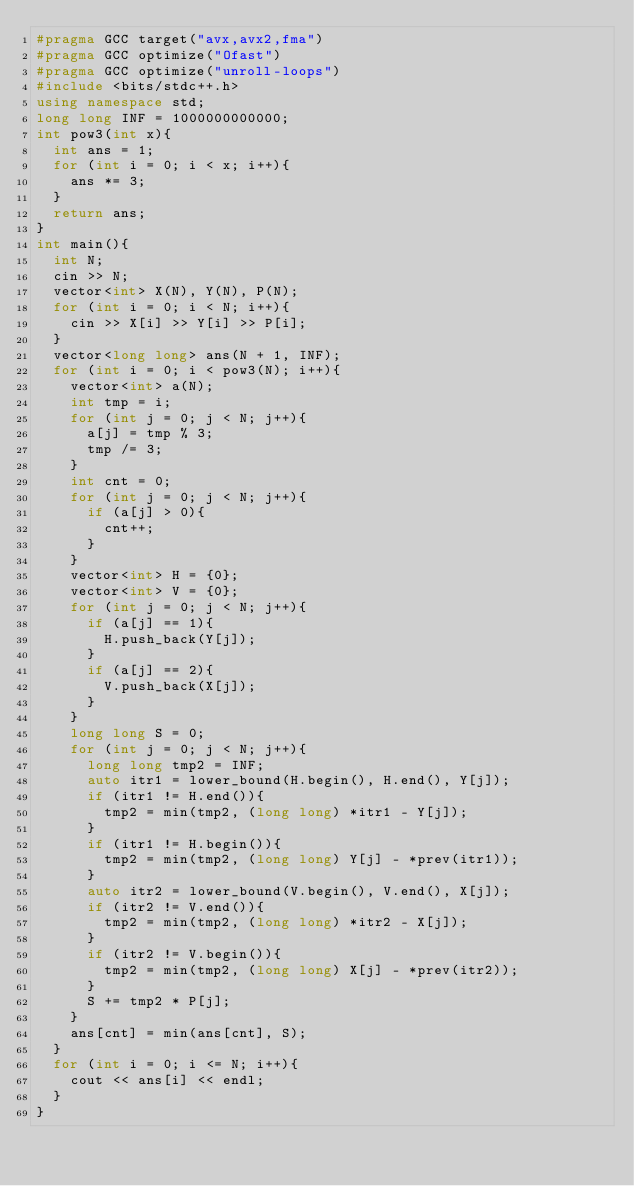<code> <loc_0><loc_0><loc_500><loc_500><_C++_>#pragma GCC target("avx,avx2,fma")
#pragma GCC optimize("Ofast")
#pragma GCC optimize("unroll-loops")
#include <bits/stdc++.h>
using namespace std;
long long INF = 1000000000000;
int pow3(int x){
  int ans = 1;
  for (int i = 0; i < x; i++){
    ans *= 3;
  }
  return ans;
}
int main(){
  int N;
  cin >> N;
  vector<int> X(N), Y(N), P(N);
  for (int i = 0; i < N; i++){
    cin >> X[i] >> Y[i] >> P[i];
  }
  vector<long long> ans(N + 1, INF);
  for (int i = 0; i < pow3(N); i++){
    vector<int> a(N);
    int tmp = i;
    for (int j = 0; j < N; j++){
      a[j] = tmp % 3;
      tmp /= 3;
    }
    int cnt = 0;
    for (int j = 0; j < N; j++){
      if (a[j] > 0){
        cnt++;
      }
    }
    vector<int> H = {0};
    vector<int> V = {0};
    for (int j = 0; j < N; j++){
      if (a[j] == 1){
        H.push_back(Y[j]);
      }
      if (a[j] == 2){
        V.push_back(X[j]);
      }
    }
    long long S = 0;
    for (int j = 0; j < N; j++){
      long long tmp2 = INF;
      auto itr1 = lower_bound(H.begin(), H.end(), Y[j]);
      if (itr1 != H.end()){
        tmp2 = min(tmp2, (long long) *itr1 - Y[j]);
      }
      if (itr1 != H.begin()){
        tmp2 = min(tmp2, (long long) Y[j] - *prev(itr1));
      }
      auto itr2 = lower_bound(V.begin(), V.end(), X[j]);
      if (itr2 != V.end()){
        tmp2 = min(tmp2, (long long) *itr2 - X[j]);
      }
      if (itr2 != V.begin()){
        tmp2 = min(tmp2, (long long) X[j] - *prev(itr2));
      }
      S += tmp2 * P[j];
    }
    ans[cnt] = min(ans[cnt], S);
  }
  for (int i = 0; i <= N; i++){
    cout << ans[i] << endl;
  }
}</code> 